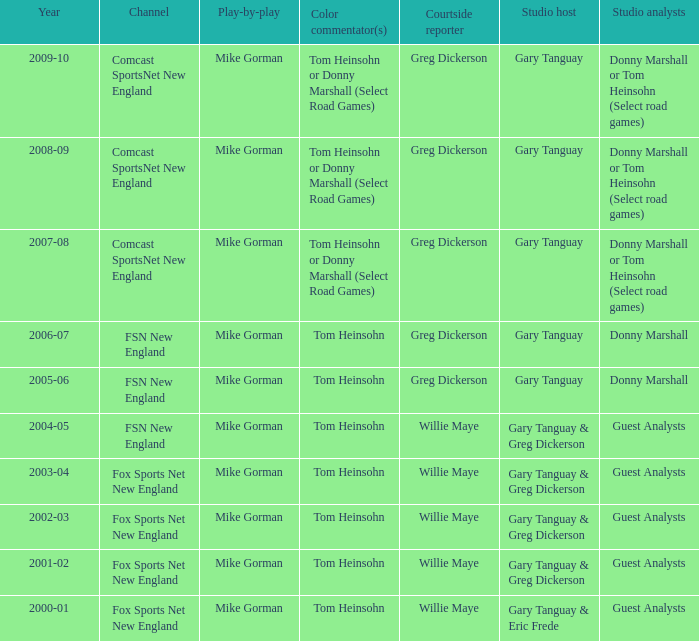Which Courtside reporter has a Channel of fsn new england in 2006-07? Greg Dickerson. Can you give me this table as a dict? {'header': ['Year', 'Channel', 'Play-by-play', 'Color commentator(s)', 'Courtside reporter', 'Studio host', 'Studio analysts'], 'rows': [['2009-10', 'Comcast SportsNet New England', 'Mike Gorman', 'Tom Heinsohn or Donny Marshall (Select Road Games)', 'Greg Dickerson', 'Gary Tanguay', 'Donny Marshall or Tom Heinsohn (Select road games)'], ['2008-09', 'Comcast SportsNet New England', 'Mike Gorman', 'Tom Heinsohn or Donny Marshall (Select Road Games)', 'Greg Dickerson', 'Gary Tanguay', 'Donny Marshall or Tom Heinsohn (Select road games)'], ['2007-08', 'Comcast SportsNet New England', 'Mike Gorman', 'Tom Heinsohn or Donny Marshall (Select Road Games)', 'Greg Dickerson', 'Gary Tanguay', 'Donny Marshall or Tom Heinsohn (Select road games)'], ['2006-07', 'FSN New England', 'Mike Gorman', 'Tom Heinsohn', 'Greg Dickerson', 'Gary Tanguay', 'Donny Marshall'], ['2005-06', 'FSN New England', 'Mike Gorman', 'Tom Heinsohn', 'Greg Dickerson', 'Gary Tanguay', 'Donny Marshall'], ['2004-05', 'FSN New England', 'Mike Gorman', 'Tom Heinsohn', 'Willie Maye', 'Gary Tanguay & Greg Dickerson', 'Guest Analysts'], ['2003-04', 'Fox Sports Net New England', 'Mike Gorman', 'Tom Heinsohn', 'Willie Maye', 'Gary Tanguay & Greg Dickerson', 'Guest Analysts'], ['2002-03', 'Fox Sports Net New England', 'Mike Gorman', 'Tom Heinsohn', 'Willie Maye', 'Gary Tanguay & Greg Dickerson', 'Guest Analysts'], ['2001-02', 'Fox Sports Net New England', 'Mike Gorman', 'Tom Heinsohn', 'Willie Maye', 'Gary Tanguay & Greg Dickerson', 'Guest Analysts'], ['2000-01', 'Fox Sports Net New England', 'Mike Gorman', 'Tom Heinsohn', 'Willie Maye', 'Gary Tanguay & Eric Frede', 'Guest Analysts']]} 